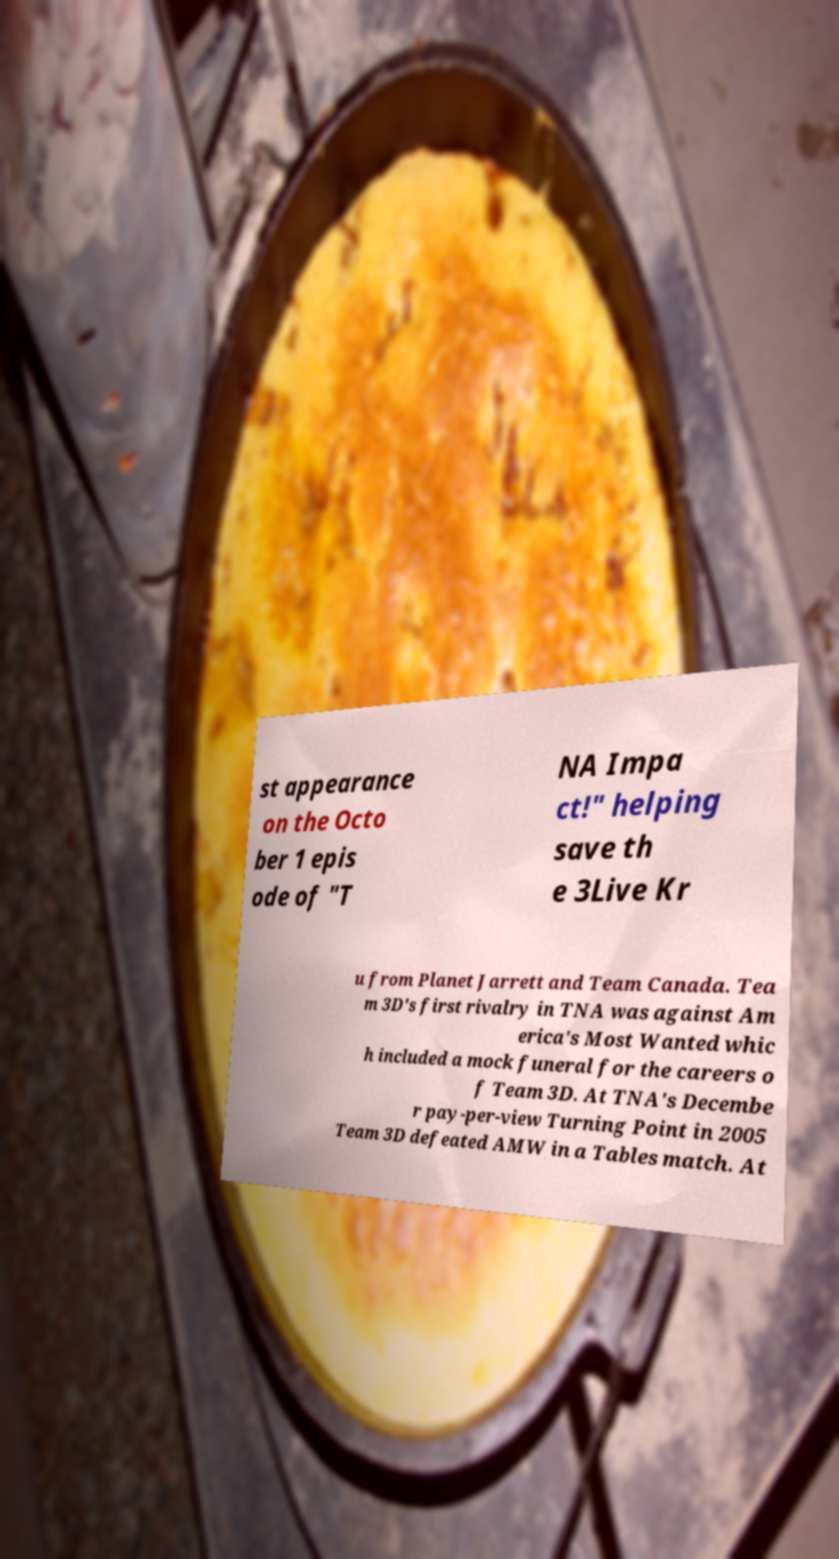Please identify and transcribe the text found in this image. st appearance on the Octo ber 1 epis ode of "T NA Impa ct!" helping save th e 3Live Kr u from Planet Jarrett and Team Canada. Tea m 3D's first rivalry in TNA was against Am erica's Most Wanted whic h included a mock funeral for the careers o f Team 3D. At TNA's Decembe r pay-per-view Turning Point in 2005 Team 3D defeated AMW in a Tables match. At 